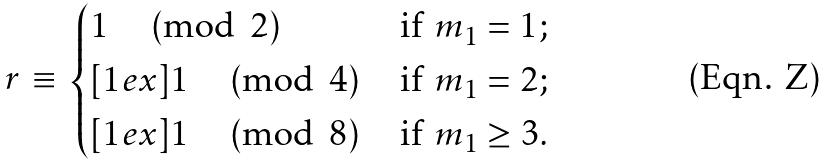Convert formula to latex. <formula><loc_0><loc_0><loc_500><loc_500>r \, \equiv \, \begin{cases} 1 \, \pmod { 2 } \, & \text {if $m_{1} = 1$} ; \\ [ 1 e x ] 1 \, \pmod { 4 } \, & \text {if $m_{1} = 2$} ; \\ [ 1 e x ] 1 \, \pmod { 8 } \, & \text {if $m_{1} \geq 3$} . \end{cases}</formula> 